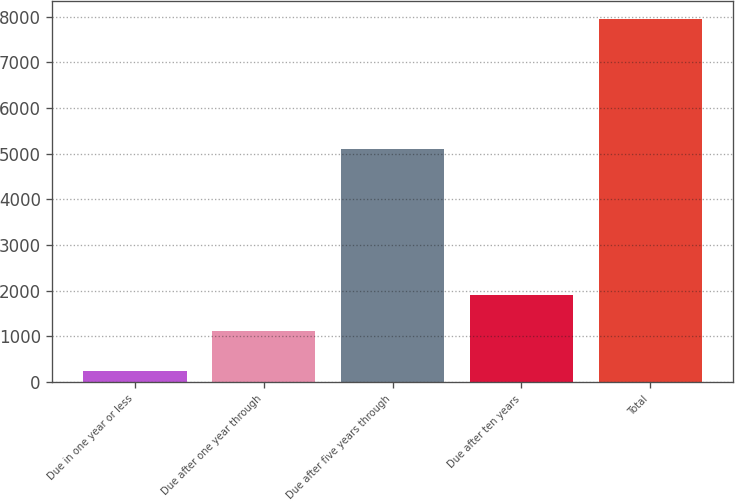Convert chart to OTSL. <chart><loc_0><loc_0><loc_500><loc_500><bar_chart><fcel>Due in one year or less<fcel>Due after one year through<fcel>Due after five years through<fcel>Due after ten years<fcel>Total<nl><fcel>252<fcel>1127<fcel>5091<fcel>1896.8<fcel>7950<nl></chart> 